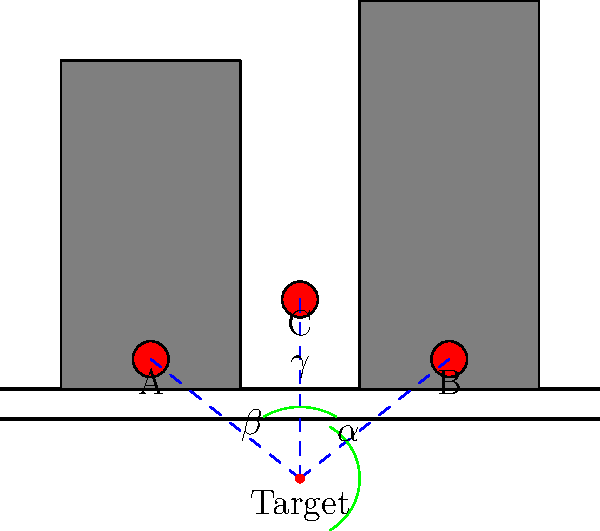In the diagram, three potential hiding spots (A, B, and C) are shown for photographing a target on the street. If the angle $\alpha = 60°$ and $\beta = 60°$, what is the measure of angle $\gamma$? To solve this problem, we'll follow these steps:

1. Recognize that the three angles ($\alpha$, $\beta$, and $\gamma$) form a complete circle around the target.
2. Recall that the sum of angles in a circle is 360°.
3. Set up an equation:
   $\alpha + \beta + \gamma = 360°$
4. Substitute the known values:
   $60° + 60° + \gamma = 360°$
5. Simplify:
   $120° + \gamma = 360°$
6. Subtract 120° from both sides:
   $\gamma = 360° - 120°$
7. Calculate the final result:
   $\gamma = 240°$

Therefore, the measure of angle $\gamma$ is 240°.
Answer: 240° 